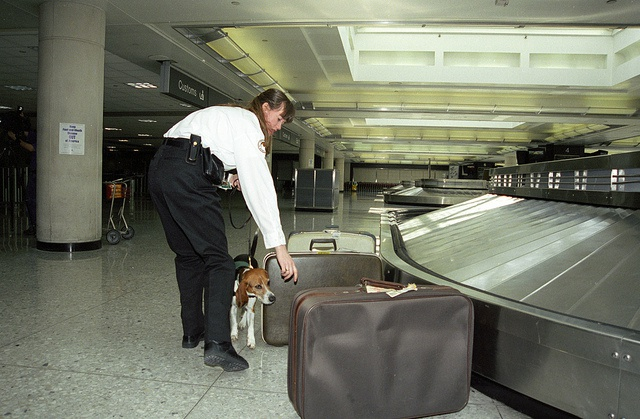Describe the objects in this image and their specific colors. I can see people in black, white, and gray tones, suitcase in black and gray tones, suitcase in black, gray, and darkgray tones, suitcase in black, beige, darkgray, and gray tones, and dog in black, lightgray, darkgray, and maroon tones in this image. 